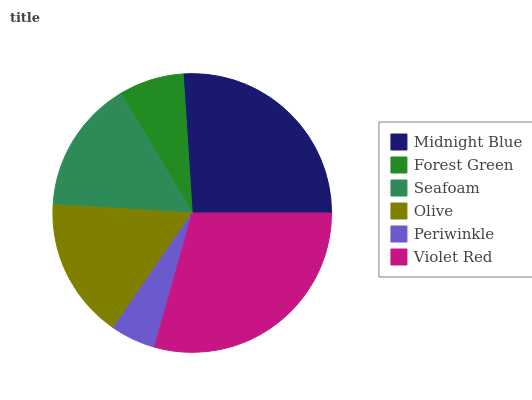Is Periwinkle the minimum?
Answer yes or no. Yes. Is Violet Red the maximum?
Answer yes or no. Yes. Is Forest Green the minimum?
Answer yes or no. No. Is Forest Green the maximum?
Answer yes or no. No. Is Midnight Blue greater than Forest Green?
Answer yes or no. Yes. Is Forest Green less than Midnight Blue?
Answer yes or no. Yes. Is Forest Green greater than Midnight Blue?
Answer yes or no. No. Is Midnight Blue less than Forest Green?
Answer yes or no. No. Is Olive the high median?
Answer yes or no. Yes. Is Seafoam the low median?
Answer yes or no. Yes. Is Midnight Blue the high median?
Answer yes or no. No. Is Midnight Blue the low median?
Answer yes or no. No. 